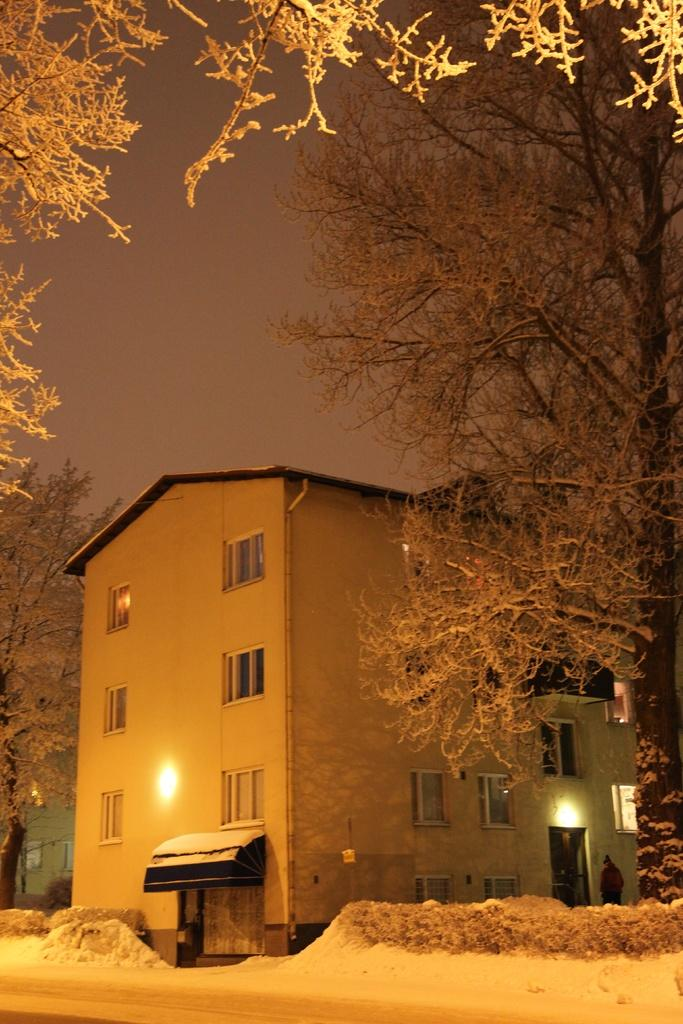What type of structure is present in the image? There is a building in the image. How is the building positioned in relation to the surrounding environment? The building is situated between trees. What can be seen at the top of the image? There are branches visible at the top of the image. What is visible in the background of the image? The sky is visible in the background of the image. What type of cattle can be seen grazing in the image? There is no cattle present in the image; it features a building situated between trees with branches and the sky visible in the background. What show is taking place in the image? There is no show depicted in the image; it shows a building, trees, branches, and the sky. 